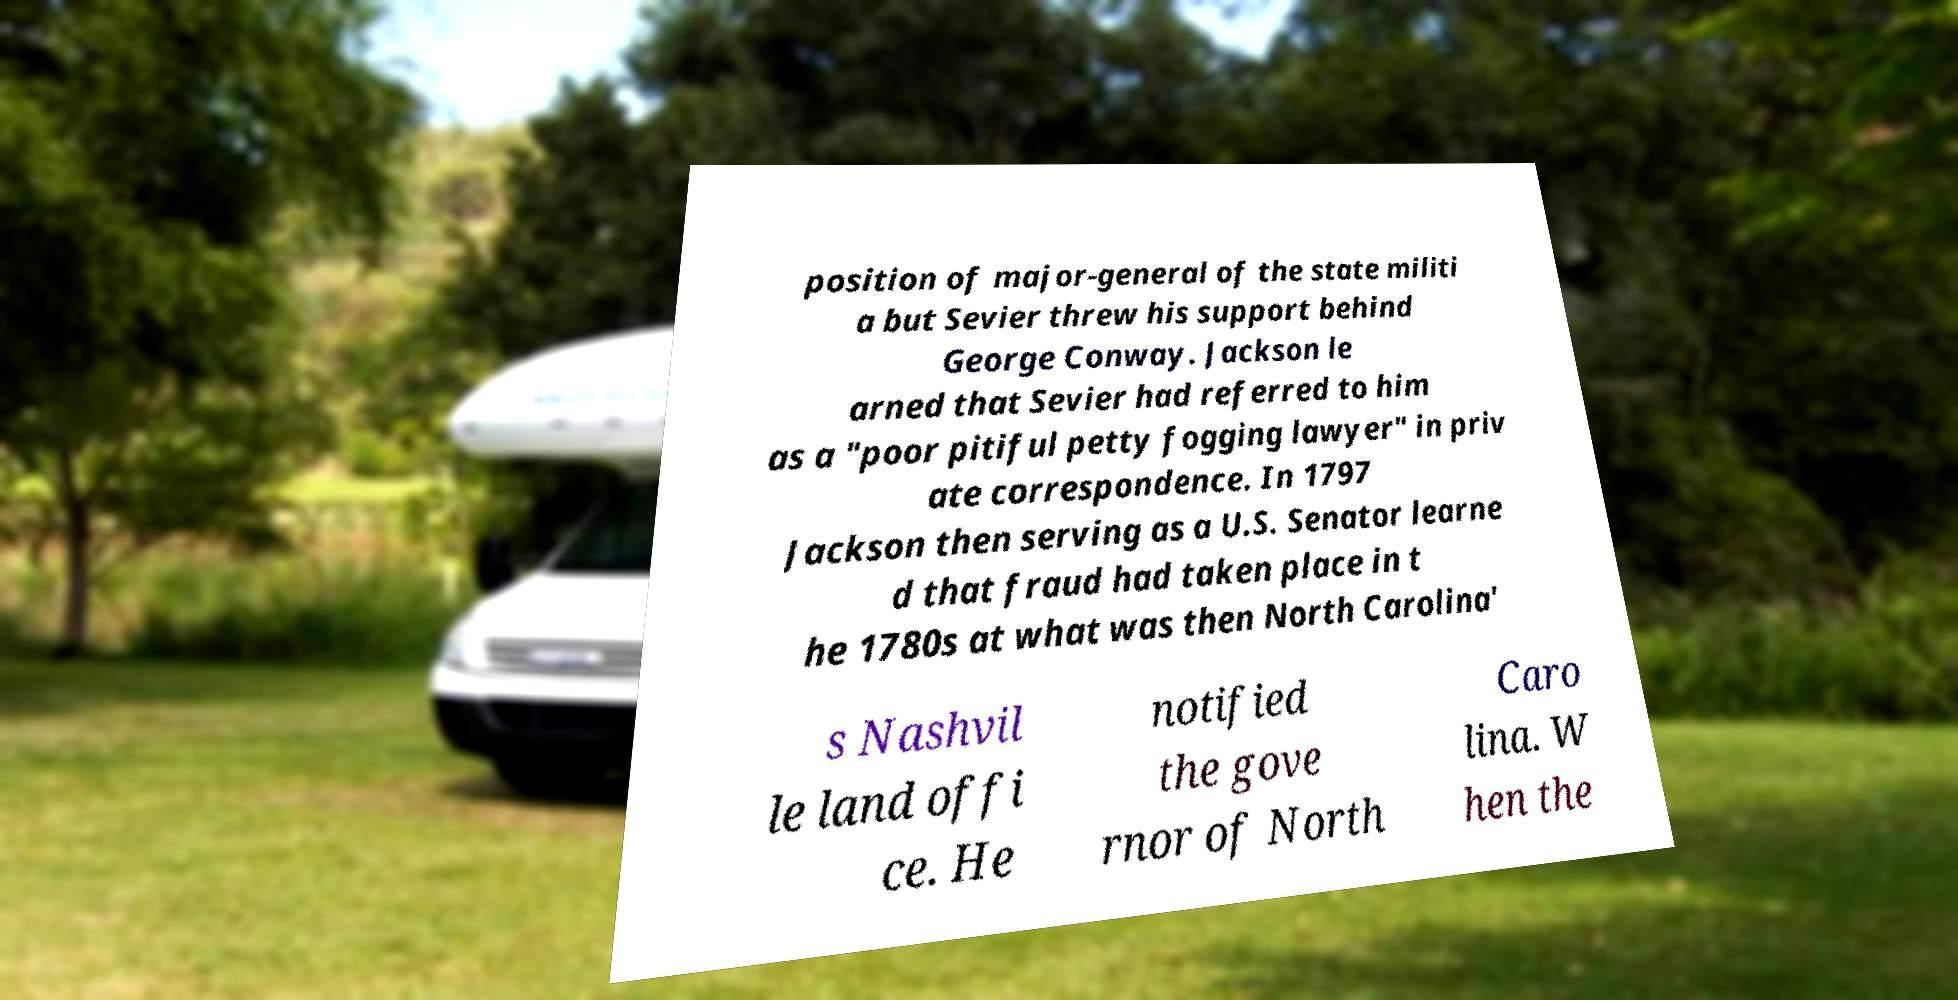I need the written content from this picture converted into text. Can you do that? position of major-general of the state militi a but Sevier threw his support behind George Conway. Jackson le arned that Sevier had referred to him as a "poor pitiful petty fogging lawyer" in priv ate correspondence. In 1797 Jackson then serving as a U.S. Senator learne d that fraud had taken place in t he 1780s at what was then North Carolina' s Nashvil le land offi ce. He notified the gove rnor of North Caro lina. W hen the 